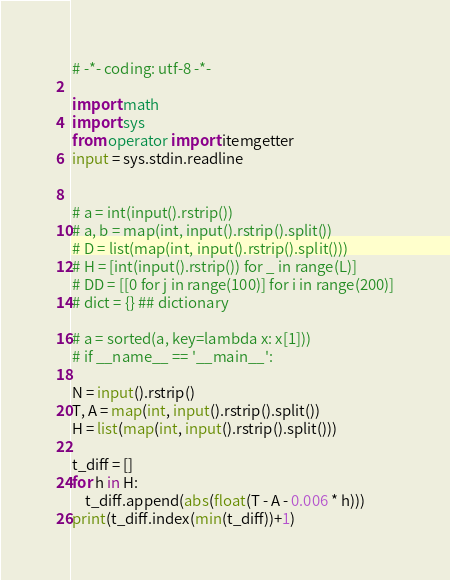Convert code to text. <code><loc_0><loc_0><loc_500><loc_500><_Python_># -*- coding: utf-8 -*-

import math
import sys
from operator import itemgetter
input = sys.stdin.readline


# a = int(input().rstrip())
# a, b = map(int, input().rstrip().split())
# D = list(map(int, input().rstrip().split()))
# H = [int(input().rstrip()) for _ in range(L)]
# DD = [[0 for j in range(100)] for i in range(200)]
# dict = {} ## dictionary

# a = sorted(a, key=lambda x: x[1]))
# if __name__ == '__main__':

N = input().rstrip()
T, A = map(int, input().rstrip().split())
H = list(map(int, input().rstrip().split()))

t_diff = []
for h in H:
	t_diff.append(abs(float(T - A - 0.006 * h)))
print(t_diff.index(min(t_diff))+1)</code> 